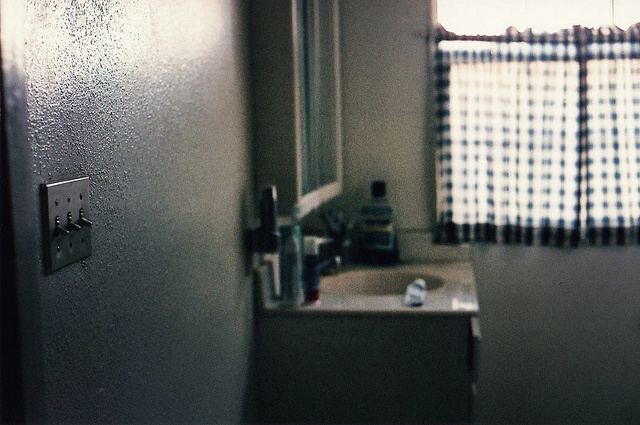Describe the objects in this image and their specific colors. I can see a sink in lightgray, gray, black, and darkgray tones in this image. 